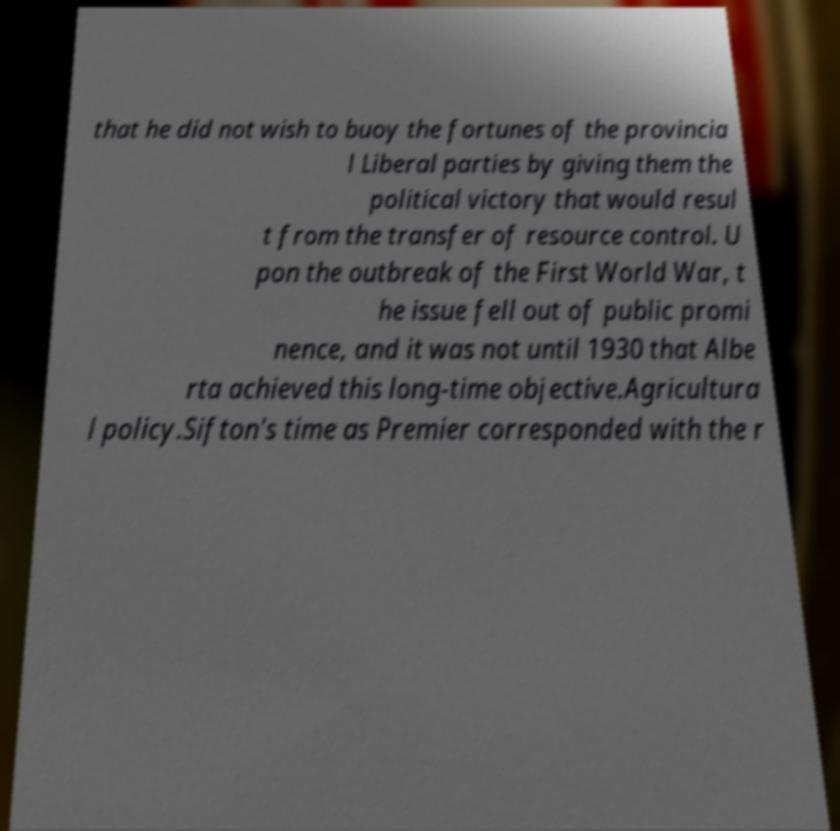Please read and relay the text visible in this image. What does it say? that he did not wish to buoy the fortunes of the provincia l Liberal parties by giving them the political victory that would resul t from the transfer of resource control. U pon the outbreak of the First World War, t he issue fell out of public promi nence, and it was not until 1930 that Albe rta achieved this long-time objective.Agricultura l policy.Sifton's time as Premier corresponded with the r 